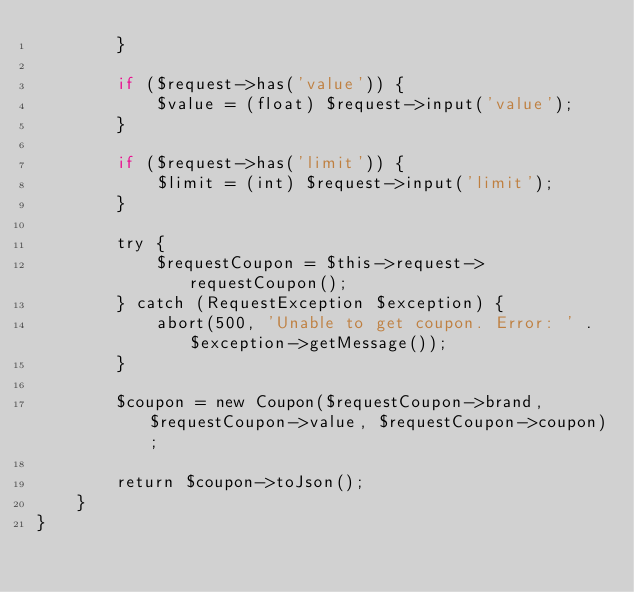Convert code to text. <code><loc_0><loc_0><loc_500><loc_500><_PHP_>        }

        if ($request->has('value')) {
            $value = (float) $request->input('value');
        }

        if ($request->has('limit')) {
            $limit = (int) $request->input('limit');
        }

        try {
            $requestCoupon = $this->request->requestCoupon();
        } catch (RequestException $exception) {
            abort(500, 'Unable to get coupon. Error: ' . $exception->getMessage());
        }

        $coupon = new Coupon($requestCoupon->brand, $requestCoupon->value, $requestCoupon->coupon);

        return $coupon->toJson();
    }
}
</code> 